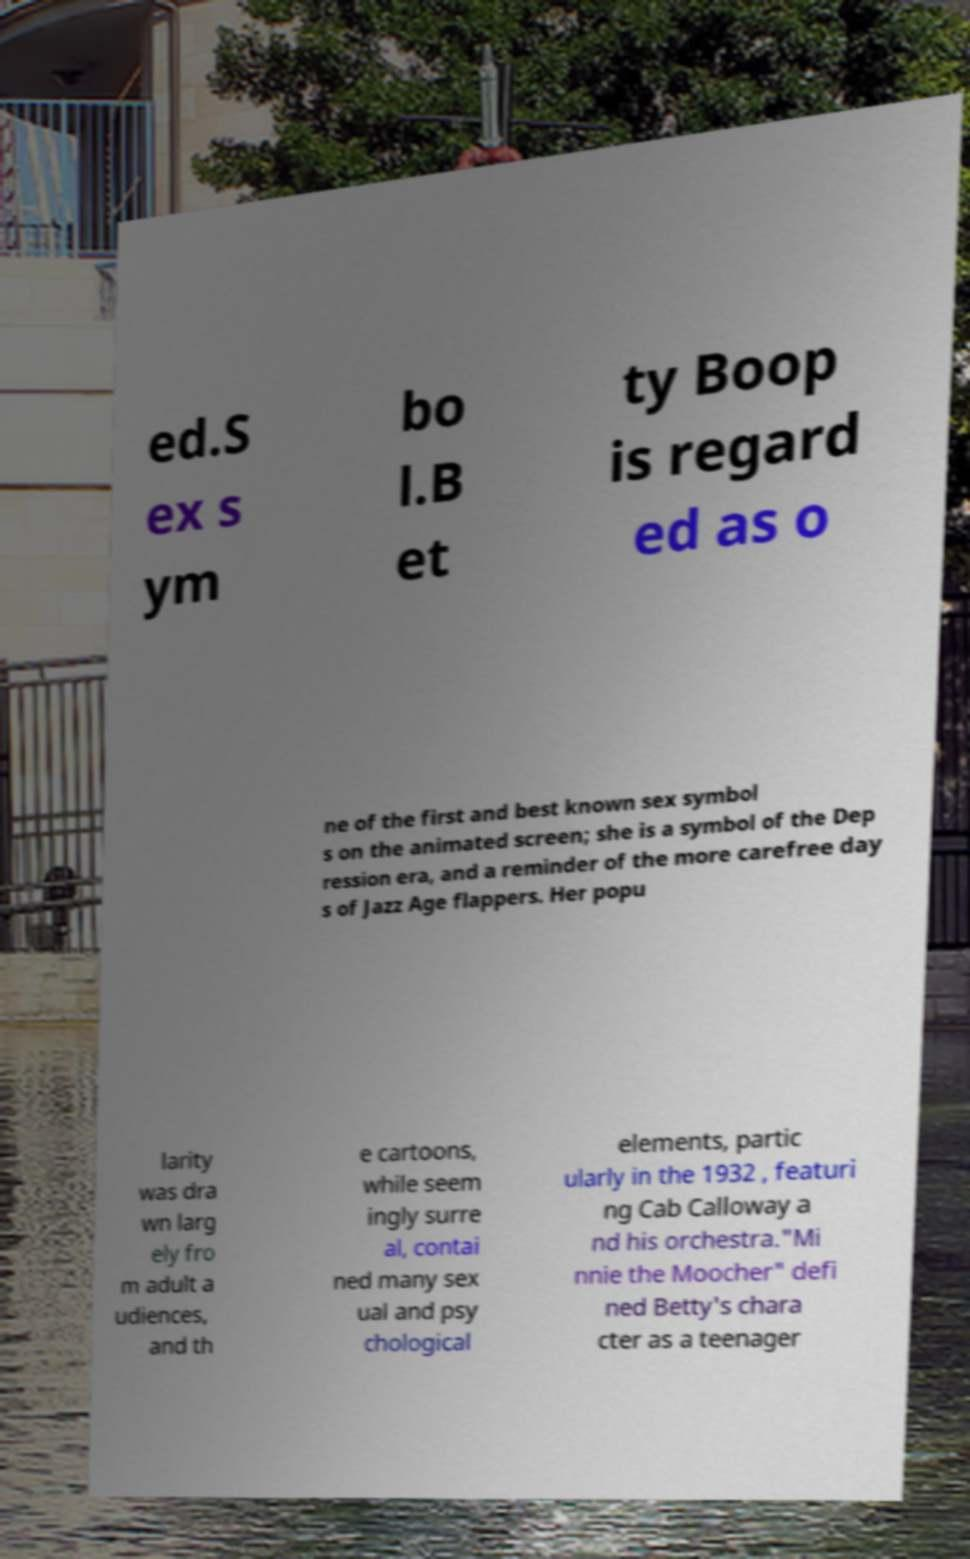Could you assist in decoding the text presented in this image and type it out clearly? ed.S ex s ym bo l.B et ty Boop is regard ed as o ne of the first and best known sex symbol s on the animated screen; she is a symbol of the Dep ression era, and a reminder of the more carefree day s of Jazz Age flappers. Her popu larity was dra wn larg ely fro m adult a udiences, and th e cartoons, while seem ingly surre al, contai ned many sex ual and psy chological elements, partic ularly in the 1932 , featuri ng Cab Calloway a nd his orchestra."Mi nnie the Moocher" defi ned Betty's chara cter as a teenager 